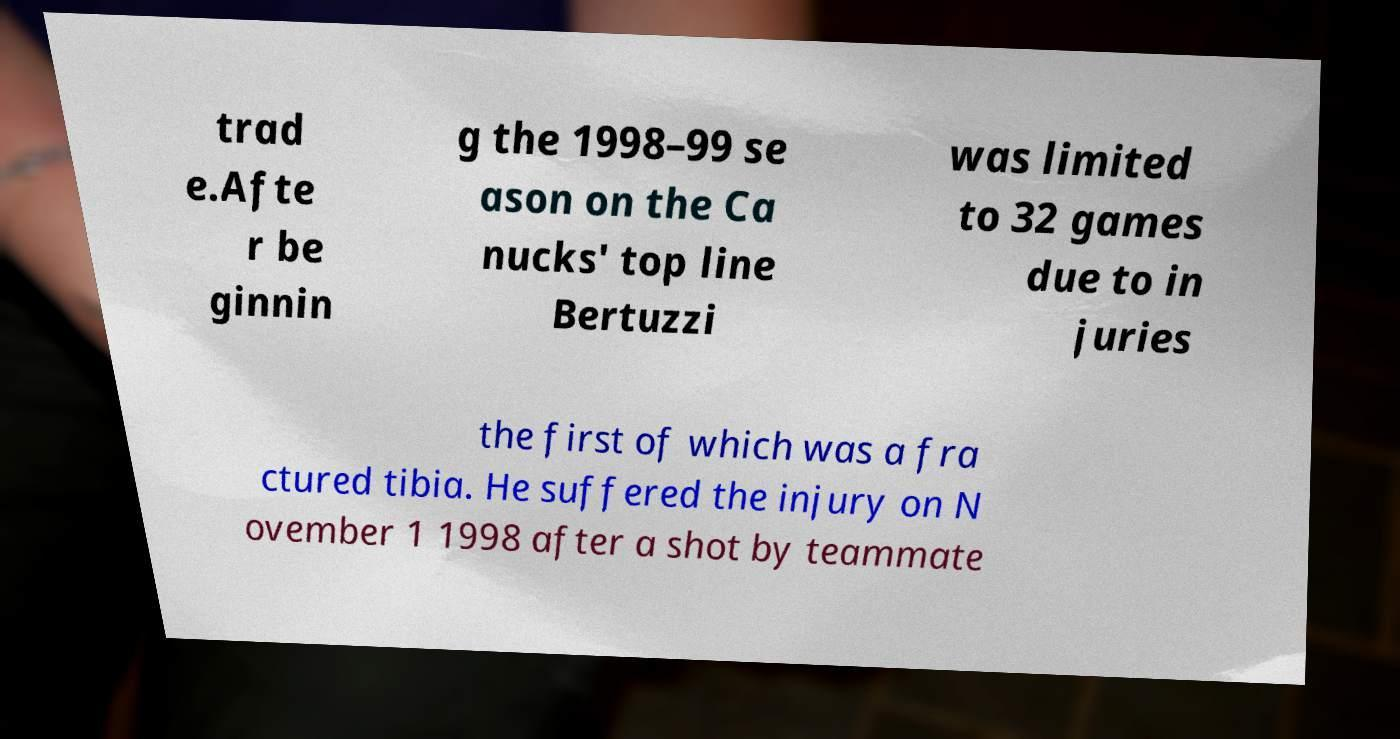Can you read and provide the text displayed in the image?This photo seems to have some interesting text. Can you extract and type it out for me? trad e.Afte r be ginnin g the 1998–99 se ason on the Ca nucks' top line Bertuzzi was limited to 32 games due to in juries the first of which was a fra ctured tibia. He suffered the injury on N ovember 1 1998 after a shot by teammate 